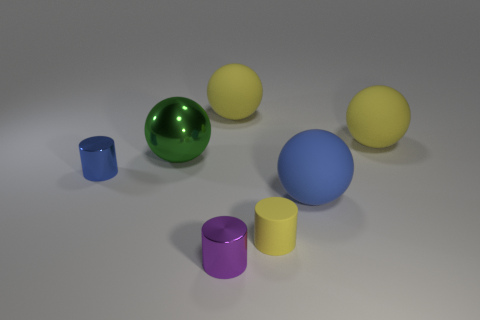Subtract 1 spheres. How many spheres are left? 3 Add 2 big rubber balls. How many objects exist? 9 Subtract all cylinders. How many objects are left? 4 Add 6 cylinders. How many cylinders exist? 9 Subtract 0 cyan cubes. How many objects are left? 7 Subtract all big rubber balls. Subtract all purple things. How many objects are left? 3 Add 1 small purple metallic cylinders. How many small purple metallic cylinders are left? 2 